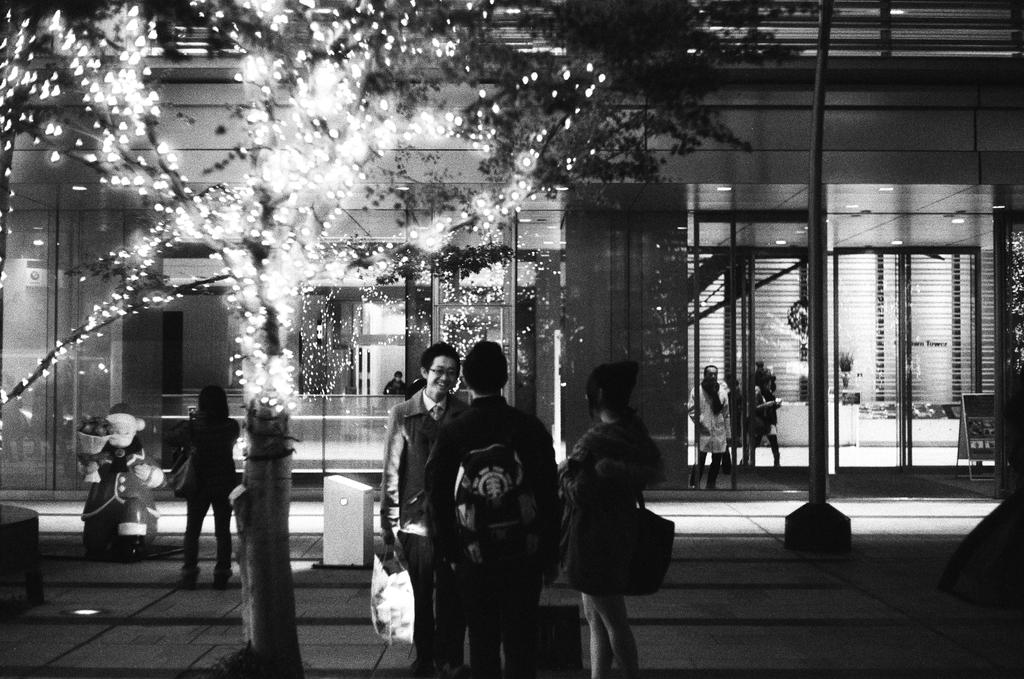What is happening in the foreground of the image? There is a group of people in the foreground of the image. Where are the people located? The group of people is on the road. What can be seen in the background of the image? There is a tree and a building in the background of the image, as well as doors. What time of day was the image taken? The image was taken during night. How many eggs are being held by the people in the image? There are no eggs visible in the image; the people are on the road and there is no mention of eggs in the provided facts. 